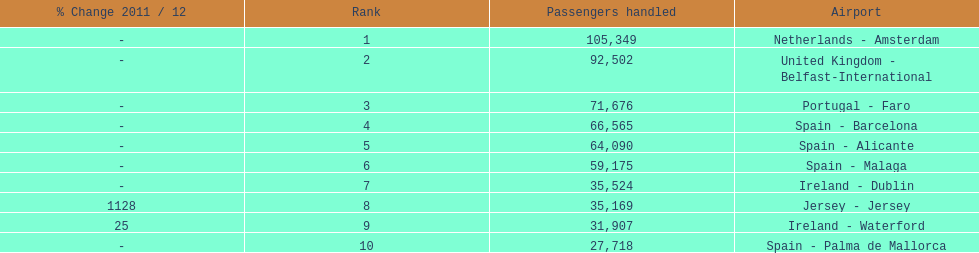Which airport had more passengers handled than the united kingdom? Netherlands - Amsterdam. 